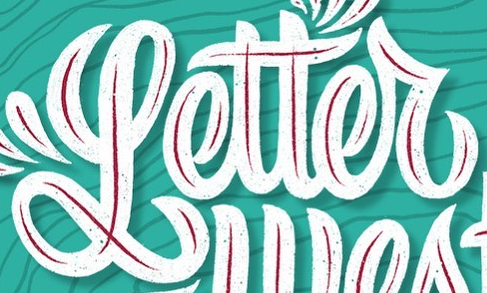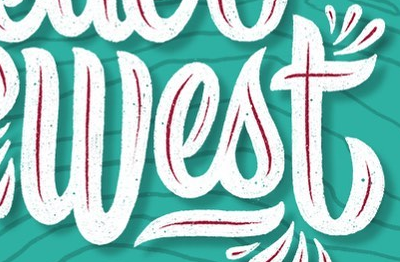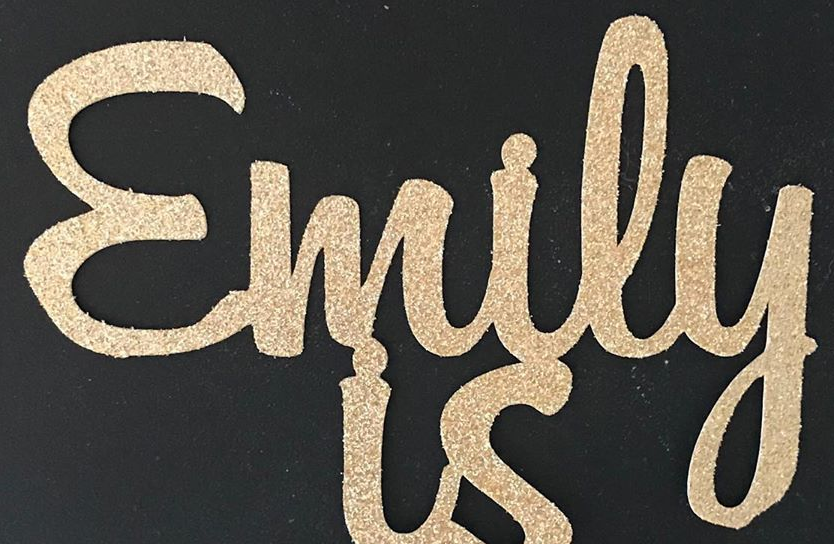Identify the words shown in these images in order, separated by a semicolon. Letter; West; Emily 